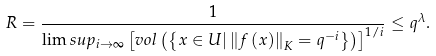Convert formula to latex. <formula><loc_0><loc_0><loc_500><loc_500>R = \frac { 1 } { \lim s u p _ { i \rightarrow \infty } \left [ v o l \left ( \left \{ x \in U | \left \| f \left ( x \right ) \right \| _ { K } = q ^ { - i } \right \} \right ) \right ] ^ { 1 / i } } \leq q ^ { \lambda } .</formula> 